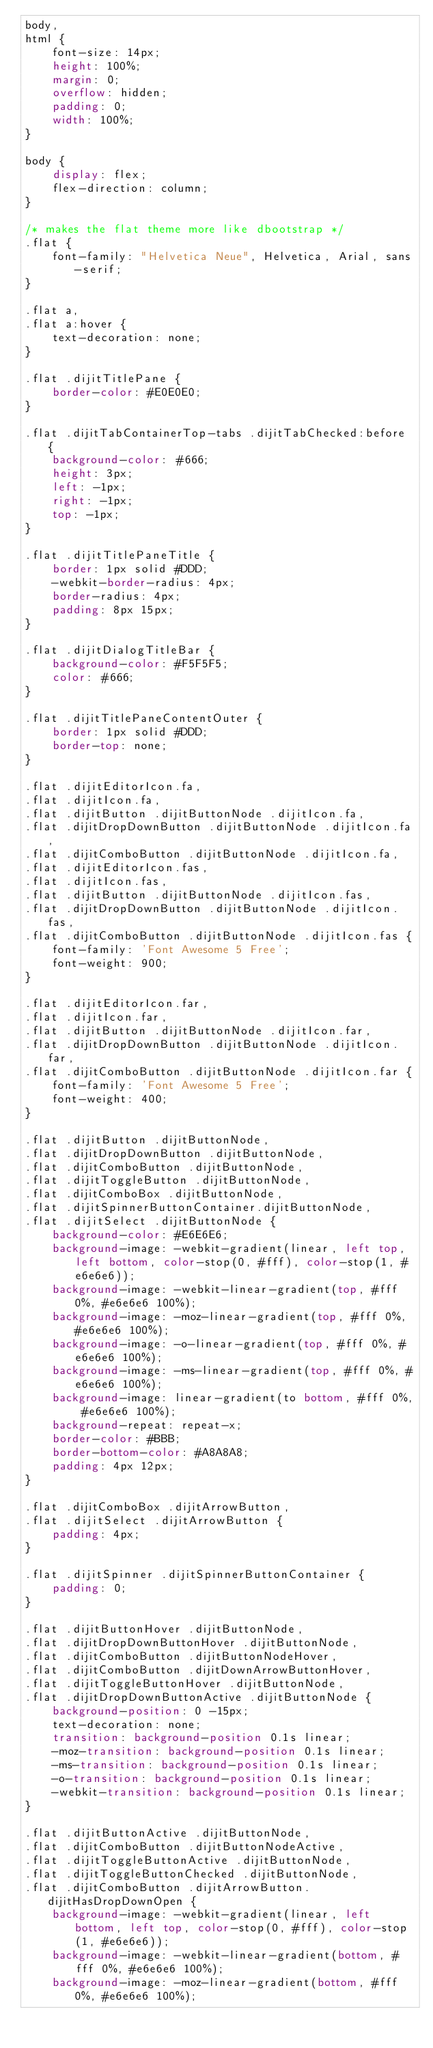<code> <loc_0><loc_0><loc_500><loc_500><_CSS_>body,
html {
    font-size: 14px;
    height: 100%;
    margin: 0;
    overflow: hidden;
    padding: 0;
    width: 100%;
}

body {
    display: flex;
    flex-direction: column;
}

/* makes the flat theme more like dbootstrap */
.flat {
    font-family: "Helvetica Neue", Helvetica, Arial, sans-serif;
}

.flat a,
.flat a:hover {
    text-decoration: none;
}

.flat .dijitTitlePane {
    border-color: #E0E0E0;
}

.flat .dijitTabContainerTop-tabs .dijitTabChecked:before {
    background-color: #666;
    height: 3px;
    left: -1px;
    right: -1px;
    top: -1px;
}

.flat .dijitTitlePaneTitle {
    border: 1px solid #DDD;
    -webkit-border-radius: 4px;
    border-radius: 4px;
    padding: 8px 15px;
}

.flat .dijitDialogTitleBar {
    background-color: #F5F5F5;
    color: #666;
}

.flat .dijitTitlePaneContentOuter {
    border: 1px solid #DDD;
    border-top: none;
}

.flat .dijitEditorIcon.fa,
.flat .dijitIcon.fa,
.flat .dijitButton .dijitButtonNode .dijitIcon.fa,
.flat .dijitDropDownButton .dijitButtonNode .dijitIcon.fa,
.flat .dijitComboButton .dijitButtonNode .dijitIcon.fa,
.flat .dijitEditorIcon.fas,
.flat .dijitIcon.fas,
.flat .dijitButton .dijitButtonNode .dijitIcon.fas,
.flat .dijitDropDownButton .dijitButtonNode .dijitIcon.fas,
.flat .dijitComboButton .dijitButtonNode .dijitIcon.fas {
    font-family: 'Font Awesome 5 Free';
    font-weight: 900;
}

.flat .dijitEditorIcon.far,
.flat .dijitIcon.far,
.flat .dijitButton .dijitButtonNode .dijitIcon.far,
.flat .dijitDropDownButton .dijitButtonNode .dijitIcon.far,
.flat .dijitComboButton .dijitButtonNode .dijitIcon.far {
    font-family: 'Font Awesome 5 Free';
    font-weight: 400;
}

.flat .dijitButton .dijitButtonNode,
.flat .dijitDropDownButton .dijitButtonNode,
.flat .dijitComboButton .dijitButtonNode,
.flat .dijitToggleButton .dijitButtonNode,
.flat .dijitComboBox .dijitButtonNode,
.flat .dijitSpinnerButtonContainer.dijitButtonNode,
.flat .dijitSelect .dijitButtonNode {
    background-color: #E6E6E6;
    background-image: -webkit-gradient(linear, left top, left bottom, color-stop(0, #fff), color-stop(1, #e6e6e6));
    background-image: -webkit-linear-gradient(top, #fff 0%, #e6e6e6 100%);
    background-image: -moz-linear-gradient(top, #fff 0%, #e6e6e6 100%);
    background-image: -o-linear-gradient(top, #fff 0%, #e6e6e6 100%);
    background-image: -ms-linear-gradient(top, #fff 0%, #e6e6e6 100%);
    background-image: linear-gradient(to bottom, #fff 0%, #e6e6e6 100%);
    background-repeat: repeat-x;
    border-color: #BBB;
    border-bottom-color: #A8A8A8;
    padding: 4px 12px;
}

.flat .dijitComboBox .dijitArrowButton,
.flat .dijitSelect .dijitArrowButton {
    padding: 4px;
}

.flat .dijitSpinner .dijitSpinnerButtonContainer {
    padding: 0;
}

.flat .dijitButtonHover .dijitButtonNode,
.flat .dijitDropDownButtonHover .dijitButtonNode,
.flat .dijitComboButton .dijitButtonNodeHover,
.flat .dijitComboButton .dijitDownArrowButtonHover,
.flat .dijitToggleButtonHover .dijitButtonNode,
.flat .dijitDropDownButtonActive .dijitButtonNode {
    background-position: 0 -15px;
    text-decoration: none;
    transition: background-position 0.1s linear;
    -moz-transition: background-position 0.1s linear;
    -ms-transition: background-position 0.1s linear;
    -o-transition: background-position 0.1s linear;
    -webkit-transition: background-position 0.1s linear;
}

.flat .dijitButtonActive .dijitButtonNode,
.flat .dijitComboButton .dijitButtonNodeActive,
.flat .dijitToggleButtonActive .dijitButtonNode,
.flat .dijitToggleButtonChecked .dijitButtonNode,
.flat .dijitComboButton .dijitArrowButton.dijitHasDropDownOpen {
    background-image: -webkit-gradient(linear, left bottom, left top, color-stop(0, #fff), color-stop(1, #e6e6e6));
    background-image: -webkit-linear-gradient(bottom, #fff 0%, #e6e6e6 100%);
    background-image: -moz-linear-gradient(bottom, #fff 0%, #e6e6e6 100%);</code> 